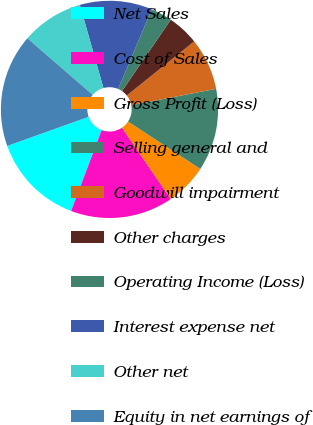Convert chart. <chart><loc_0><loc_0><loc_500><loc_500><pie_chart><fcel>Net Sales<fcel>Cost of Sales<fcel>Gross Profit (Loss)<fcel>Selling general and<fcel>Goodwill impairment<fcel>Other charges<fcel>Operating Income (Loss)<fcel>Interest expense net<fcel>Other net<fcel>Equity in net earnings of<nl><fcel>13.79%<fcel>15.3%<fcel>6.21%<fcel>12.27%<fcel>7.73%<fcel>4.7%<fcel>3.18%<fcel>10.76%<fcel>9.24%<fcel>16.82%<nl></chart> 